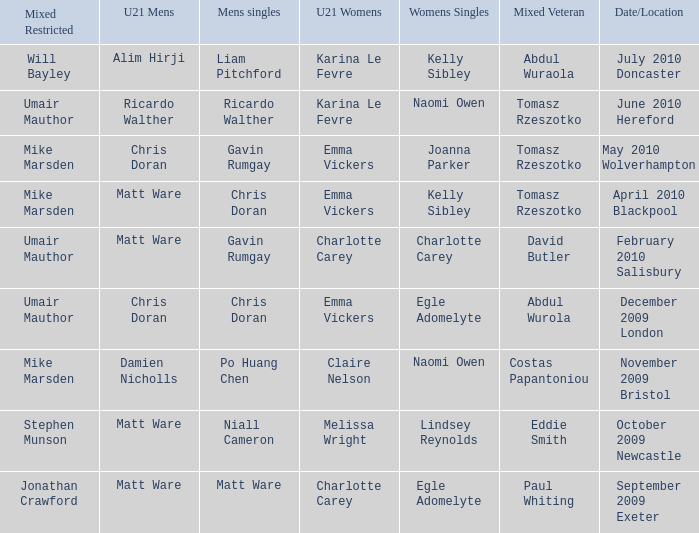Give me the full table as a dictionary. {'header': ['Mixed Restricted', 'U21 Mens', 'Mens singles', 'U21 Womens', 'Womens Singles', 'Mixed Veteran', 'Date/Location'], 'rows': [['Will Bayley', 'Alim Hirji', 'Liam Pitchford', 'Karina Le Fevre', 'Kelly Sibley', 'Abdul Wuraola', 'July 2010 Doncaster'], ['Umair Mauthor', 'Ricardo Walther', 'Ricardo Walther', 'Karina Le Fevre', 'Naomi Owen', 'Tomasz Rzeszotko', 'June 2010 Hereford'], ['Mike Marsden', 'Chris Doran', 'Gavin Rumgay', 'Emma Vickers', 'Joanna Parker', 'Tomasz Rzeszotko', 'May 2010 Wolverhampton'], ['Mike Marsden', 'Matt Ware', 'Chris Doran', 'Emma Vickers', 'Kelly Sibley', 'Tomasz Rzeszotko', 'April 2010 Blackpool'], ['Umair Mauthor', 'Matt Ware', 'Gavin Rumgay', 'Charlotte Carey', 'Charlotte Carey', 'David Butler', 'February 2010 Salisbury'], ['Umair Mauthor', 'Chris Doran', 'Chris Doran', 'Emma Vickers', 'Egle Adomelyte', 'Abdul Wurola', 'December 2009 London'], ['Mike Marsden', 'Damien Nicholls', 'Po Huang Chen', 'Claire Nelson', 'Naomi Owen', 'Costas Papantoniou', 'November 2009 Bristol'], ['Stephen Munson', 'Matt Ware', 'Niall Cameron', 'Melissa Wright', 'Lindsey Reynolds', 'Eddie Smith', 'October 2009 Newcastle'], ['Jonathan Crawford', 'Matt Ware', 'Matt Ware', 'Charlotte Carey', 'Egle Adomelyte', 'Paul Whiting', 'September 2009 Exeter']]} When Naomi Owen won the Womens Singles and Ricardo Walther won the Mens Singles, who won the mixed veteran? Tomasz Rzeszotko. 